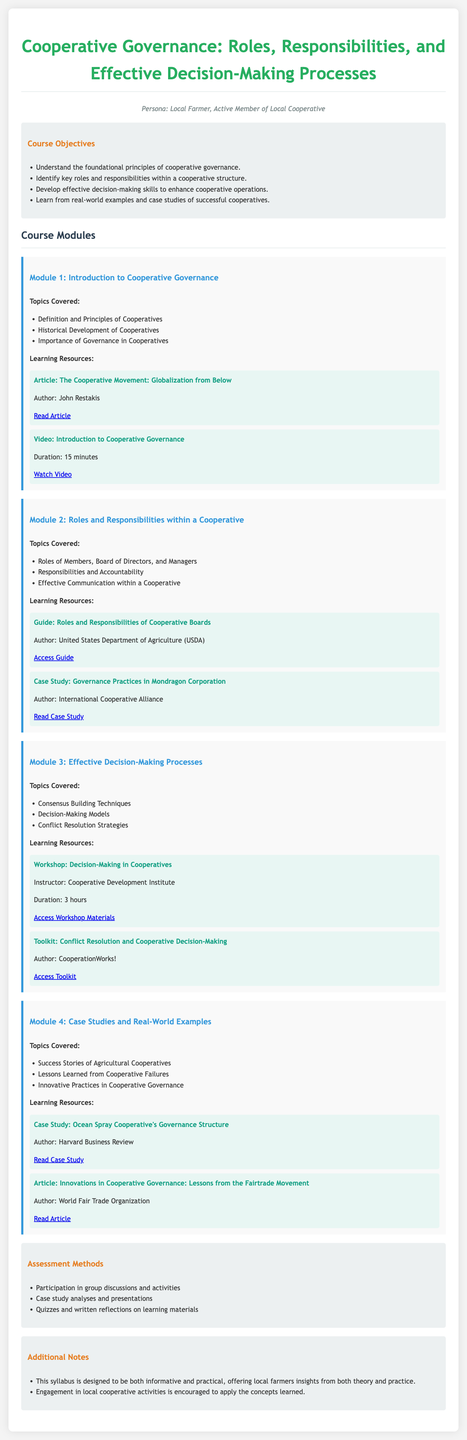What are the foundational principles of cooperative governance? The foundational principles of cooperative governance are outlined in the course objectives, which include understanding cooperative governance, identifying roles, developing decision-making skills, and learning from case studies.
Answer: Foundational principles of cooperative governance What is the duration of the video resource in Module 1? The duration of the video resource in Module 1 is specified in the learning resources section under Module 1.
Answer: 15 minutes Who authored the guide on Roles and Responsibilities of Cooperative Boards? The guide on Roles and Responsibilities of Cooperative Boards is attributed to a specific author mentioned in the learning resources of Module 2.
Answer: United States Department of Agriculture (USDA) What type of workshop is included in Module 3? The type of workshop mentioned in Module 3 focuses on decision-making processes in cooperatives, as stated in the topics covered.
Answer: Decision-Making in Cooperatives What is one of the methods of assessment mentioned in the syllabus? The assessment methods in the syllabus include several types, one of which is highlighted in the assessment methods section.
Answer: Participation in group discussions and activities What is covered in Module 4 regarding cooperative governance? Module 4 includes a specific focus on success stories and lessons learned from agricultural cooperatives as part of the topics covered.
Answer: Success Stories of Agricultural Cooperatives What is the primary aim of the course according to the objectives? The primary aim of the course is described in the course objectives, focusing on understanding cooperative governance.
Answer: Understand the foundational principles of cooperative governance What type of case study is included in the syllabus? The syllabus includes a specific case study type that provides insights into cooperative governance practices.
Answer: Case Study: Ocean Spray Cooperative's Governance Structure 